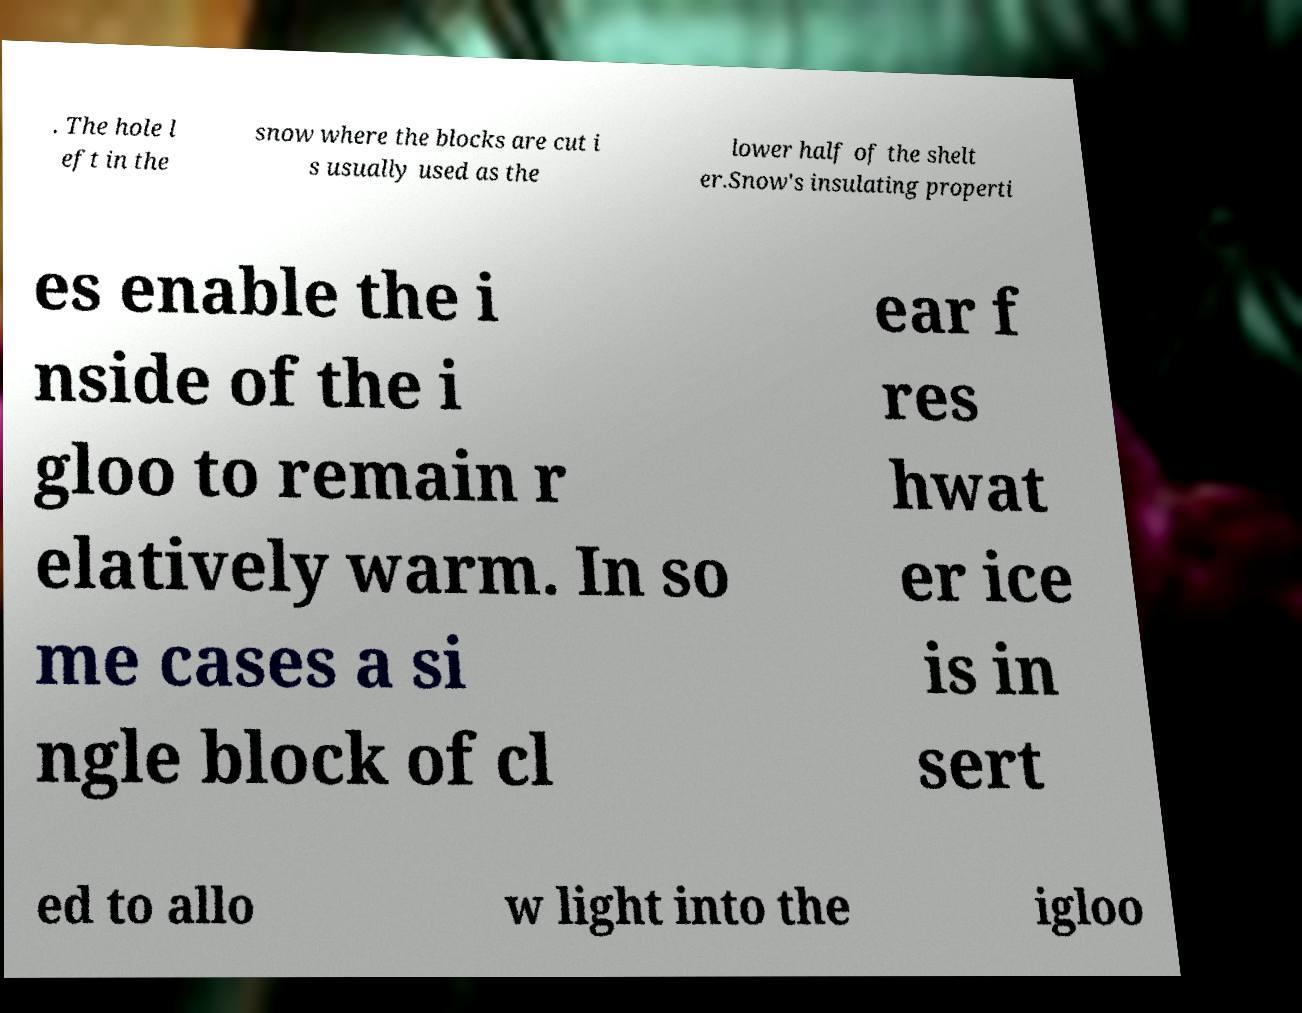Please read and relay the text visible in this image. What does it say? . The hole l eft in the snow where the blocks are cut i s usually used as the lower half of the shelt er.Snow's insulating properti es enable the i nside of the i gloo to remain r elatively warm. In so me cases a si ngle block of cl ear f res hwat er ice is in sert ed to allo w light into the igloo 